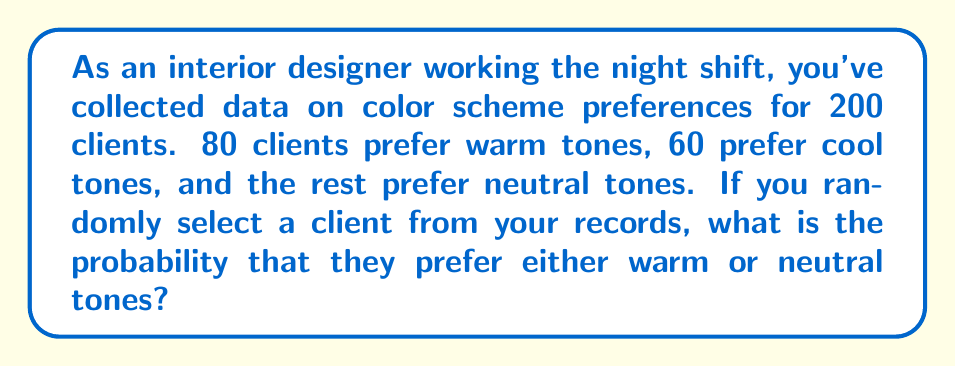Teach me how to tackle this problem. Let's approach this step-by-step:

1. First, let's identify the given information:
   - Total number of clients: 200
   - Clients preferring warm tones: 80
   - Clients preferring cool tones: 60

2. Calculate the number of clients preferring neutral tones:
   $200 - (80 + 60) = 60$ clients prefer neutral tones

3. To find the probability of selecting a client who prefers either warm or neutral tones, we need to add these two groups together:
   Warm tones + Neutral tones = $80 + 60 = 140$ clients

4. The probability is calculated by dividing the number of favorable outcomes by the total number of possible outcomes:

   $$P(\text{warm or neutral}) = \frac{\text{number of clients preferring warm or neutral}}{\text{total number of clients}}$$

   $$P(\text{warm or neutral}) = \frac{140}{200}$$

5. Simplify the fraction:
   $$P(\text{warm or neutral}) = \frac{7}{10} = 0.7$$

Therefore, the probability of randomly selecting a client who prefers either warm or neutral tones is 0.7 or 70%.
Answer: $\frac{7}{10}$ or 0.7 